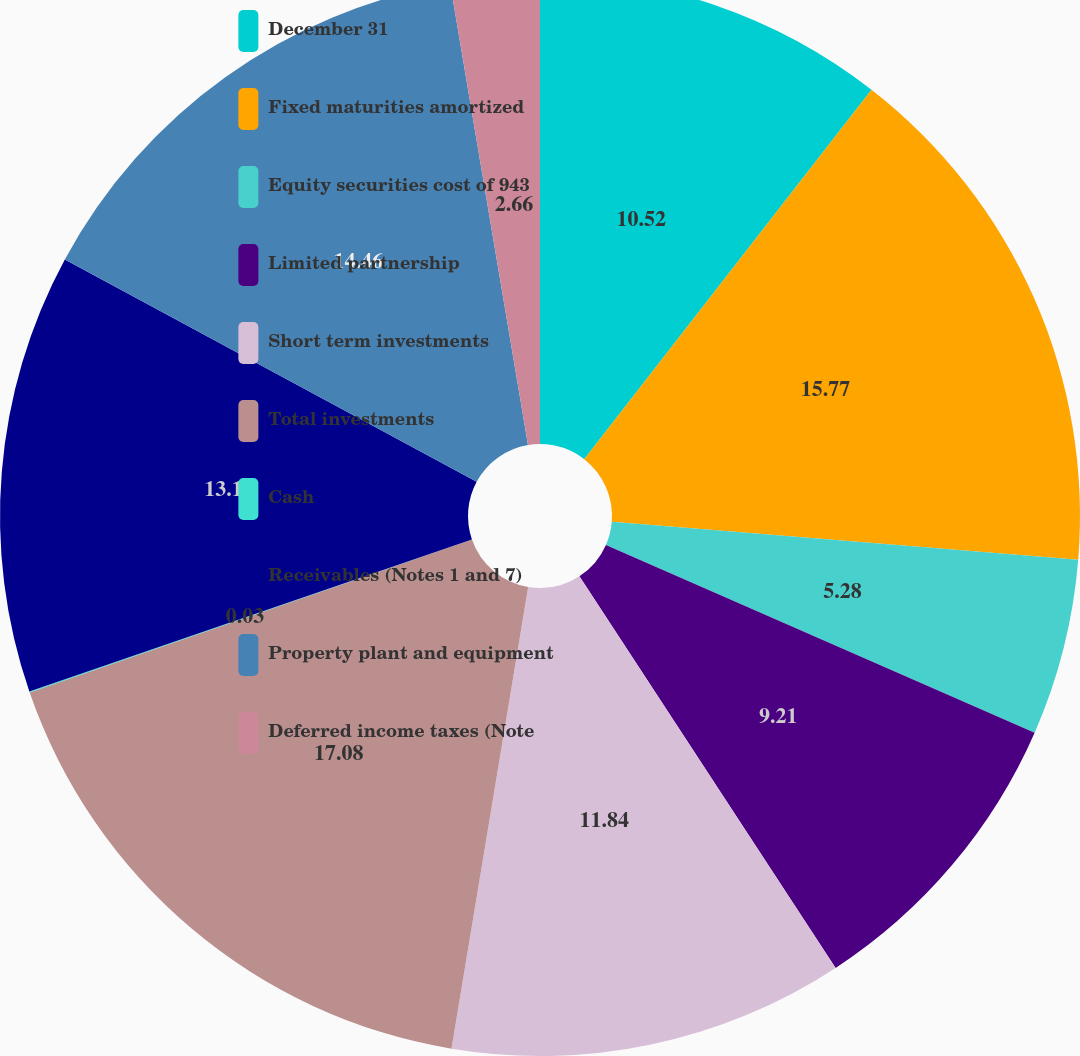Convert chart to OTSL. <chart><loc_0><loc_0><loc_500><loc_500><pie_chart><fcel>December 31<fcel>Fixed maturities amortized<fcel>Equity securities cost of 943<fcel>Limited partnership<fcel>Short term investments<fcel>Total investments<fcel>Cash<fcel>Receivables (Notes 1 and 7)<fcel>Property plant and equipment<fcel>Deferred income taxes (Note<nl><fcel>10.52%<fcel>15.77%<fcel>5.28%<fcel>9.21%<fcel>11.84%<fcel>17.08%<fcel>0.03%<fcel>13.15%<fcel>14.46%<fcel>2.66%<nl></chart> 